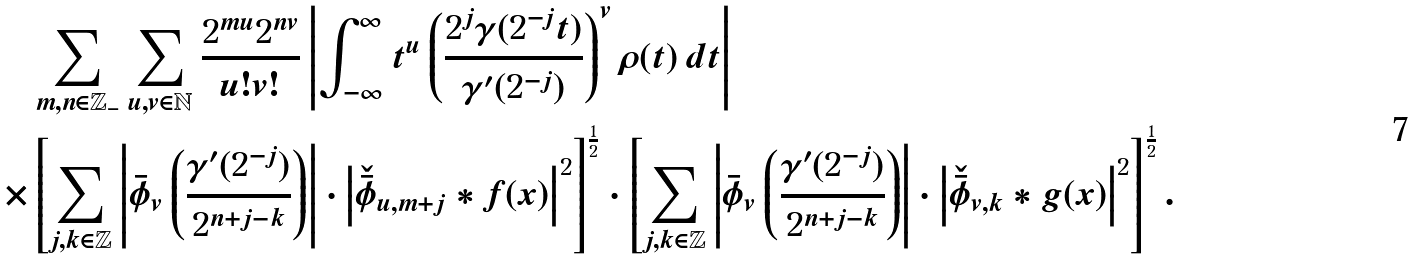Convert formula to latex. <formula><loc_0><loc_0><loc_500><loc_500>& \sum _ { m , n \in \mathbb { Z _ { - } } } \sum _ { u , v \in \mathbb { N } } \frac { 2 ^ { m u } 2 ^ { n v } } { u ! v ! } \left | \int _ { - \infty } ^ { \infty } t ^ { u } \left ( \frac { 2 ^ { j } \gamma ( 2 ^ { - j } t ) } { \gamma ^ { \prime } ( 2 ^ { - j } ) } \right ) ^ { v } \rho ( t ) \, d t \right | \\ \times & \left [ \sum _ { j , k \in \mathbb { Z } } \left | \bar { \phi } _ { v } \left ( \frac { \gamma ^ { \prime } ( 2 ^ { - j } ) } { 2 ^ { n + j - k } } \right ) \right | \cdot \left | \check { \bar { \phi } } _ { u , m + j } \ast f ( x ) \right | ^ { 2 } \right ] ^ { \frac { 1 } { 2 } } \cdot \left [ \sum _ { j , k \in \mathbb { Z } } \left | \bar { \phi } _ { v } \left ( \frac { \gamma ^ { \prime } ( 2 ^ { - j } ) } { 2 ^ { n + j - k } } \right ) \right | \cdot \left | \check { \bar { \phi } } _ { v , k } \ast g ( x ) \right | ^ { 2 } \right ] ^ { \frac { 1 } { 2 } } .</formula> 